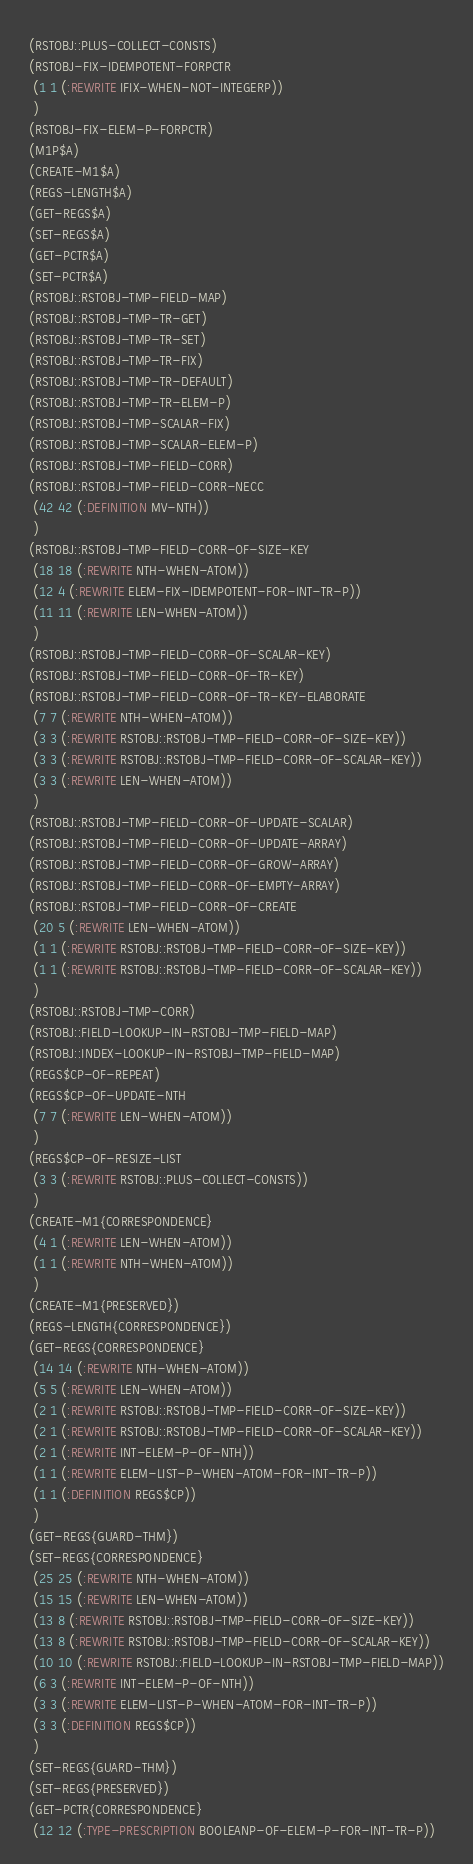Convert code to text. <code><loc_0><loc_0><loc_500><loc_500><_Lisp_>(RSTOBJ::PLUS-COLLECT-CONSTS)
(RSTOBJ-FIX-IDEMPOTENT-FORPCTR
 (1 1 (:REWRITE IFIX-WHEN-NOT-INTEGERP))
 )
(RSTOBJ-FIX-ELEM-P-FORPCTR)
(M1P$A)
(CREATE-M1$A)
(REGS-LENGTH$A)
(GET-REGS$A)
(SET-REGS$A)
(GET-PCTR$A)
(SET-PCTR$A)
(RSTOBJ::RSTOBJ-TMP-FIELD-MAP)
(RSTOBJ::RSTOBJ-TMP-TR-GET)
(RSTOBJ::RSTOBJ-TMP-TR-SET)
(RSTOBJ::RSTOBJ-TMP-TR-FIX)
(RSTOBJ::RSTOBJ-TMP-TR-DEFAULT)
(RSTOBJ::RSTOBJ-TMP-TR-ELEM-P)
(RSTOBJ::RSTOBJ-TMP-SCALAR-FIX)
(RSTOBJ::RSTOBJ-TMP-SCALAR-ELEM-P)
(RSTOBJ::RSTOBJ-TMP-FIELD-CORR)
(RSTOBJ::RSTOBJ-TMP-FIELD-CORR-NECC
 (42 42 (:DEFINITION MV-NTH))
 )
(RSTOBJ::RSTOBJ-TMP-FIELD-CORR-OF-SIZE-KEY
 (18 18 (:REWRITE NTH-WHEN-ATOM))
 (12 4 (:REWRITE ELEM-FIX-IDEMPOTENT-FOR-INT-TR-P))
 (11 11 (:REWRITE LEN-WHEN-ATOM))
 )
(RSTOBJ::RSTOBJ-TMP-FIELD-CORR-OF-SCALAR-KEY)
(RSTOBJ::RSTOBJ-TMP-FIELD-CORR-OF-TR-KEY)
(RSTOBJ::RSTOBJ-TMP-FIELD-CORR-OF-TR-KEY-ELABORATE
 (7 7 (:REWRITE NTH-WHEN-ATOM))
 (3 3 (:REWRITE RSTOBJ::RSTOBJ-TMP-FIELD-CORR-OF-SIZE-KEY))
 (3 3 (:REWRITE RSTOBJ::RSTOBJ-TMP-FIELD-CORR-OF-SCALAR-KEY))
 (3 3 (:REWRITE LEN-WHEN-ATOM))
 )
(RSTOBJ::RSTOBJ-TMP-FIELD-CORR-OF-UPDATE-SCALAR)
(RSTOBJ::RSTOBJ-TMP-FIELD-CORR-OF-UPDATE-ARRAY)
(RSTOBJ::RSTOBJ-TMP-FIELD-CORR-OF-GROW-ARRAY)
(RSTOBJ::RSTOBJ-TMP-FIELD-CORR-OF-EMPTY-ARRAY)
(RSTOBJ::RSTOBJ-TMP-FIELD-CORR-OF-CREATE
 (20 5 (:REWRITE LEN-WHEN-ATOM))
 (1 1 (:REWRITE RSTOBJ::RSTOBJ-TMP-FIELD-CORR-OF-SIZE-KEY))
 (1 1 (:REWRITE RSTOBJ::RSTOBJ-TMP-FIELD-CORR-OF-SCALAR-KEY))
 )
(RSTOBJ::RSTOBJ-TMP-CORR)
(RSTOBJ::FIELD-LOOKUP-IN-RSTOBJ-TMP-FIELD-MAP)
(RSTOBJ::INDEX-LOOKUP-IN-RSTOBJ-TMP-FIELD-MAP)
(REGS$CP-OF-REPEAT)
(REGS$CP-OF-UPDATE-NTH
 (7 7 (:REWRITE LEN-WHEN-ATOM))
 )
(REGS$CP-OF-RESIZE-LIST
 (3 3 (:REWRITE RSTOBJ::PLUS-COLLECT-CONSTS))
 )
(CREATE-M1{CORRESPONDENCE}
 (4 1 (:REWRITE LEN-WHEN-ATOM))
 (1 1 (:REWRITE NTH-WHEN-ATOM))
 )
(CREATE-M1{PRESERVED})
(REGS-LENGTH{CORRESPONDENCE})
(GET-REGS{CORRESPONDENCE}
 (14 14 (:REWRITE NTH-WHEN-ATOM))
 (5 5 (:REWRITE LEN-WHEN-ATOM))
 (2 1 (:REWRITE RSTOBJ::RSTOBJ-TMP-FIELD-CORR-OF-SIZE-KEY))
 (2 1 (:REWRITE RSTOBJ::RSTOBJ-TMP-FIELD-CORR-OF-SCALAR-KEY))
 (2 1 (:REWRITE INT-ELEM-P-OF-NTH))
 (1 1 (:REWRITE ELEM-LIST-P-WHEN-ATOM-FOR-INT-TR-P))
 (1 1 (:DEFINITION REGS$CP))
 )
(GET-REGS{GUARD-THM})
(SET-REGS{CORRESPONDENCE}
 (25 25 (:REWRITE NTH-WHEN-ATOM))
 (15 15 (:REWRITE LEN-WHEN-ATOM))
 (13 8 (:REWRITE RSTOBJ::RSTOBJ-TMP-FIELD-CORR-OF-SIZE-KEY))
 (13 8 (:REWRITE RSTOBJ::RSTOBJ-TMP-FIELD-CORR-OF-SCALAR-KEY))
 (10 10 (:REWRITE RSTOBJ::FIELD-LOOKUP-IN-RSTOBJ-TMP-FIELD-MAP))
 (6 3 (:REWRITE INT-ELEM-P-OF-NTH))
 (3 3 (:REWRITE ELEM-LIST-P-WHEN-ATOM-FOR-INT-TR-P))
 (3 3 (:DEFINITION REGS$CP))
 )
(SET-REGS{GUARD-THM})
(SET-REGS{PRESERVED})
(GET-PCTR{CORRESPONDENCE}
 (12 12 (:TYPE-PRESCRIPTION BOOLEANP-OF-ELEM-P-FOR-INT-TR-P))</code> 